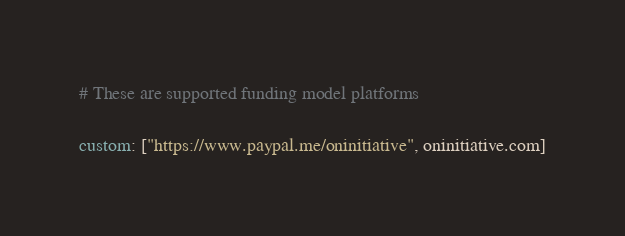<code> <loc_0><loc_0><loc_500><loc_500><_YAML_># These are supported funding model platforms

custom: ["https://www.paypal.me/oninitiative", oninitiative.com]
</code> 